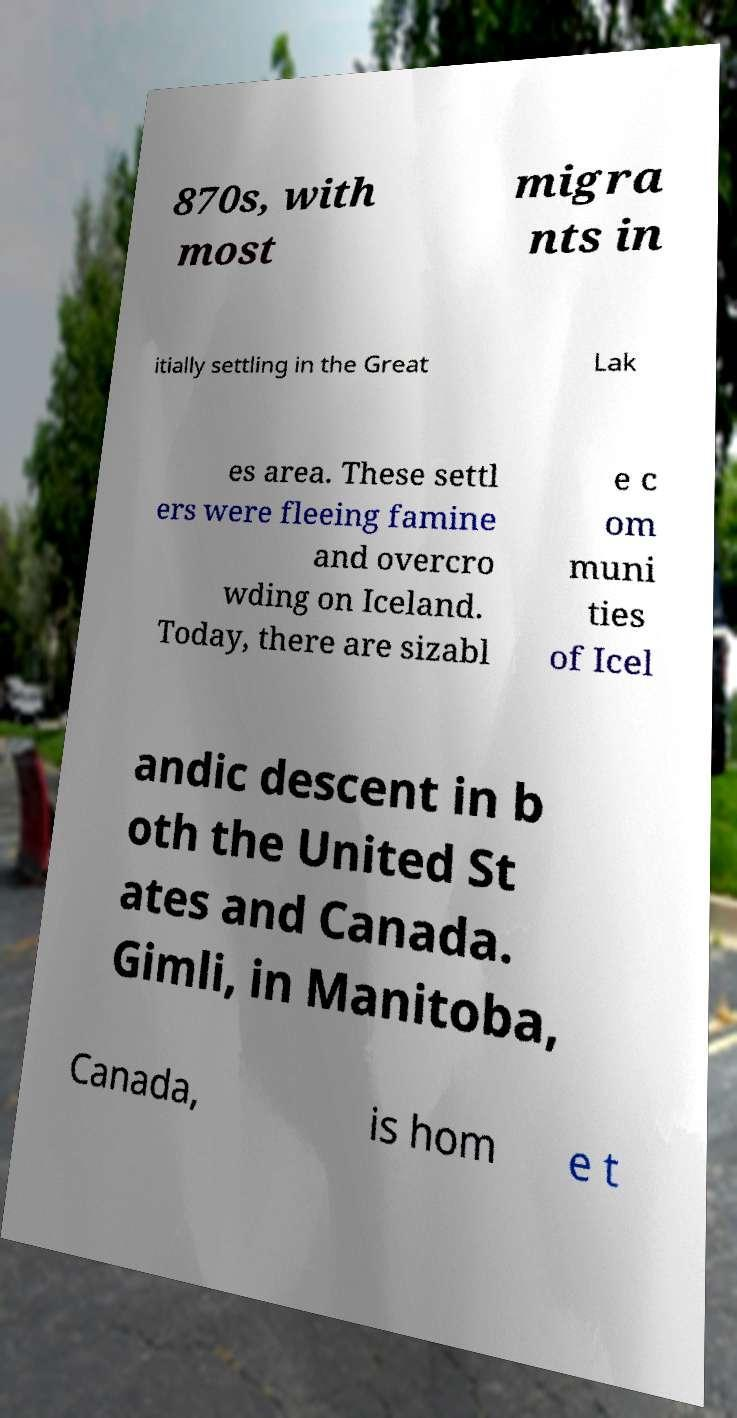Please read and relay the text visible in this image. What does it say? 870s, with most migra nts in itially settling in the Great Lak es area. These settl ers were fleeing famine and overcro wding on Iceland. Today, there are sizabl e c om muni ties of Icel andic descent in b oth the United St ates and Canada. Gimli, in Manitoba, Canada, is hom e t 